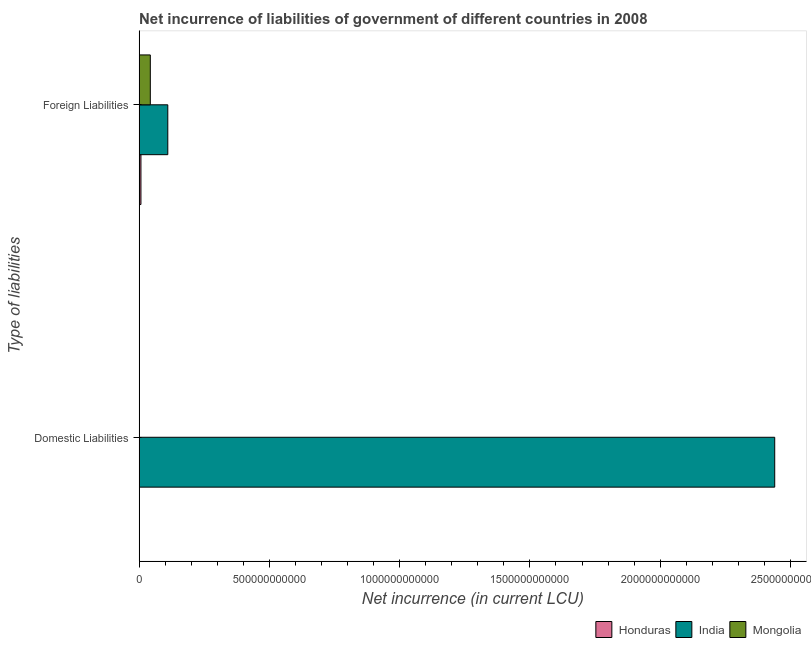How many different coloured bars are there?
Your answer should be very brief. 3. How many bars are there on the 2nd tick from the top?
Provide a succinct answer. 1. What is the label of the 2nd group of bars from the top?
Keep it short and to the point. Domestic Liabilities. What is the net incurrence of foreign liabilities in Honduras?
Your response must be concise. 7.05e+09. Across all countries, what is the maximum net incurrence of domestic liabilities?
Your answer should be very brief. 2.44e+12. Across all countries, what is the minimum net incurrence of domestic liabilities?
Ensure brevity in your answer.  0. What is the total net incurrence of domestic liabilities in the graph?
Your answer should be compact. 2.44e+12. What is the difference between the net incurrence of foreign liabilities in Honduras and that in Mongolia?
Keep it short and to the point. -3.60e+1. What is the difference between the net incurrence of domestic liabilities in Mongolia and the net incurrence of foreign liabilities in Honduras?
Keep it short and to the point. -7.05e+09. What is the average net incurrence of foreign liabilities per country?
Provide a succinct answer. 5.34e+1. What is the difference between the net incurrence of domestic liabilities and net incurrence of foreign liabilities in India?
Keep it short and to the point. 2.33e+12. What is the difference between two consecutive major ticks on the X-axis?
Ensure brevity in your answer.  5.00e+11. Does the graph contain any zero values?
Provide a short and direct response. Yes. Does the graph contain grids?
Provide a short and direct response. No. How are the legend labels stacked?
Ensure brevity in your answer.  Horizontal. What is the title of the graph?
Your answer should be very brief. Net incurrence of liabilities of government of different countries in 2008. Does "Mauritius" appear as one of the legend labels in the graph?
Your answer should be very brief. No. What is the label or title of the X-axis?
Provide a succinct answer. Net incurrence (in current LCU). What is the label or title of the Y-axis?
Ensure brevity in your answer.  Type of liabilities. What is the Net incurrence (in current LCU) of India in Domestic Liabilities?
Ensure brevity in your answer.  2.44e+12. What is the Net incurrence (in current LCU) of Honduras in Foreign Liabilities?
Your response must be concise. 7.05e+09. What is the Net incurrence (in current LCU) of India in Foreign Liabilities?
Give a very brief answer. 1.10e+11. What is the Net incurrence (in current LCU) of Mongolia in Foreign Liabilities?
Offer a very short reply. 4.30e+1. Across all Type of liabilities, what is the maximum Net incurrence (in current LCU) of Honduras?
Offer a very short reply. 7.05e+09. Across all Type of liabilities, what is the maximum Net incurrence (in current LCU) in India?
Ensure brevity in your answer.  2.44e+12. Across all Type of liabilities, what is the maximum Net incurrence (in current LCU) in Mongolia?
Offer a terse response. 4.30e+1. Across all Type of liabilities, what is the minimum Net incurrence (in current LCU) in India?
Keep it short and to the point. 1.10e+11. What is the total Net incurrence (in current LCU) in Honduras in the graph?
Offer a terse response. 7.05e+09. What is the total Net incurrence (in current LCU) in India in the graph?
Your answer should be very brief. 2.55e+12. What is the total Net incurrence (in current LCU) of Mongolia in the graph?
Your answer should be very brief. 4.30e+1. What is the difference between the Net incurrence (in current LCU) of India in Domestic Liabilities and that in Foreign Liabilities?
Your answer should be compact. 2.33e+12. What is the difference between the Net incurrence (in current LCU) of India in Domestic Liabilities and the Net incurrence (in current LCU) of Mongolia in Foreign Liabilities?
Provide a short and direct response. 2.40e+12. What is the average Net incurrence (in current LCU) of Honduras per Type of liabilities?
Your response must be concise. 3.53e+09. What is the average Net incurrence (in current LCU) in India per Type of liabilities?
Ensure brevity in your answer.  1.27e+12. What is the average Net incurrence (in current LCU) of Mongolia per Type of liabilities?
Provide a short and direct response. 2.15e+1. What is the difference between the Net incurrence (in current LCU) in Honduras and Net incurrence (in current LCU) in India in Foreign Liabilities?
Your answer should be very brief. -1.03e+11. What is the difference between the Net incurrence (in current LCU) in Honduras and Net incurrence (in current LCU) in Mongolia in Foreign Liabilities?
Give a very brief answer. -3.60e+1. What is the difference between the Net incurrence (in current LCU) in India and Net incurrence (in current LCU) in Mongolia in Foreign Liabilities?
Make the answer very short. 6.71e+1. What is the ratio of the Net incurrence (in current LCU) in India in Domestic Liabilities to that in Foreign Liabilities?
Your response must be concise. 22.15. What is the difference between the highest and the second highest Net incurrence (in current LCU) of India?
Give a very brief answer. 2.33e+12. What is the difference between the highest and the lowest Net incurrence (in current LCU) of Honduras?
Offer a terse response. 7.05e+09. What is the difference between the highest and the lowest Net incurrence (in current LCU) of India?
Your answer should be compact. 2.33e+12. What is the difference between the highest and the lowest Net incurrence (in current LCU) of Mongolia?
Provide a succinct answer. 4.30e+1. 